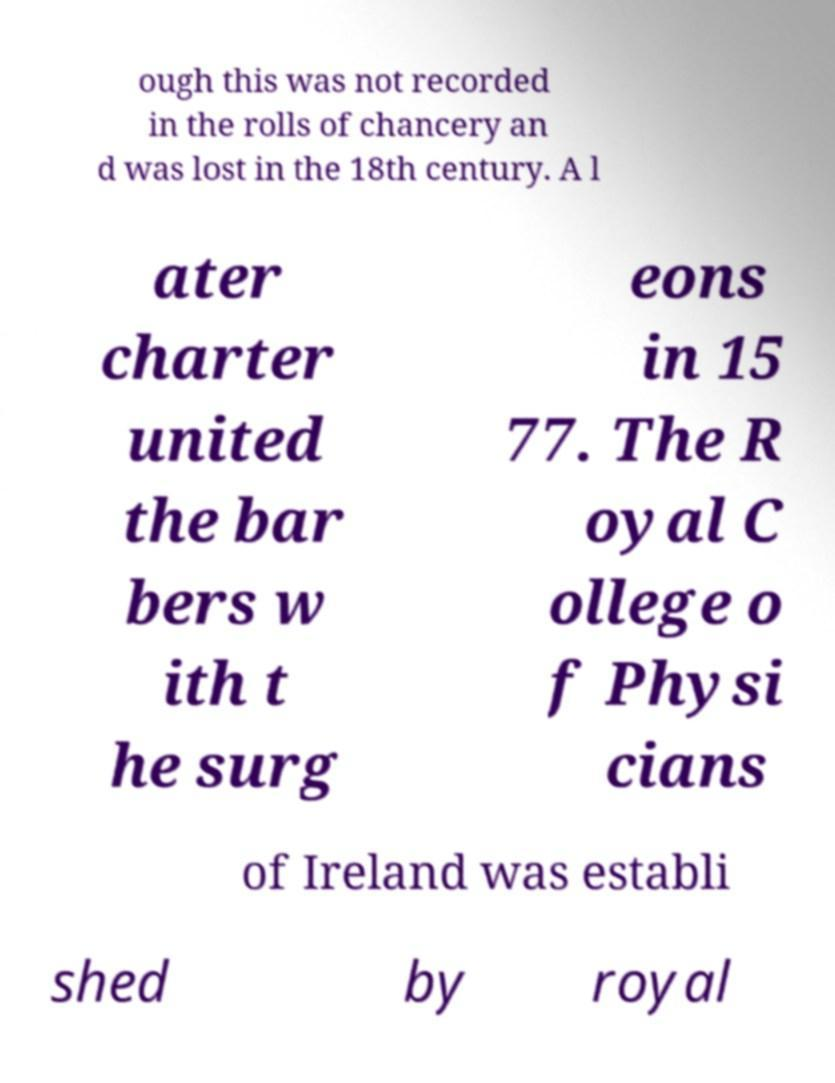Please read and relay the text visible in this image. What does it say? ough this was not recorded in the rolls of chancery an d was lost in the 18th century. A l ater charter united the bar bers w ith t he surg eons in 15 77. The R oyal C ollege o f Physi cians of Ireland was establi shed by royal 